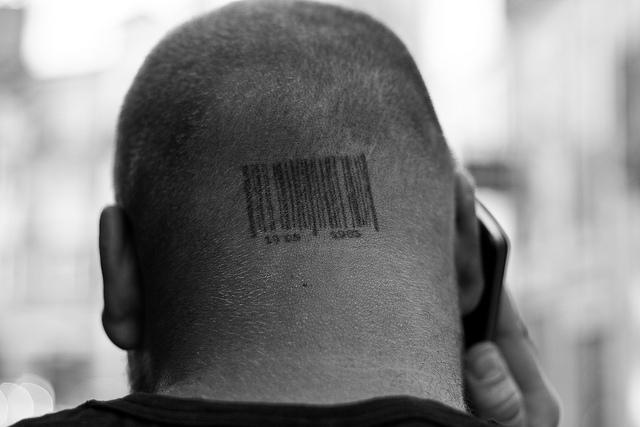Is the tattoo an actual UPC code for something?
Quick response, please. No. Is the man on the phone?
Concise answer only. Yes. Where is the man's tattoo?
Concise answer only. Head. 